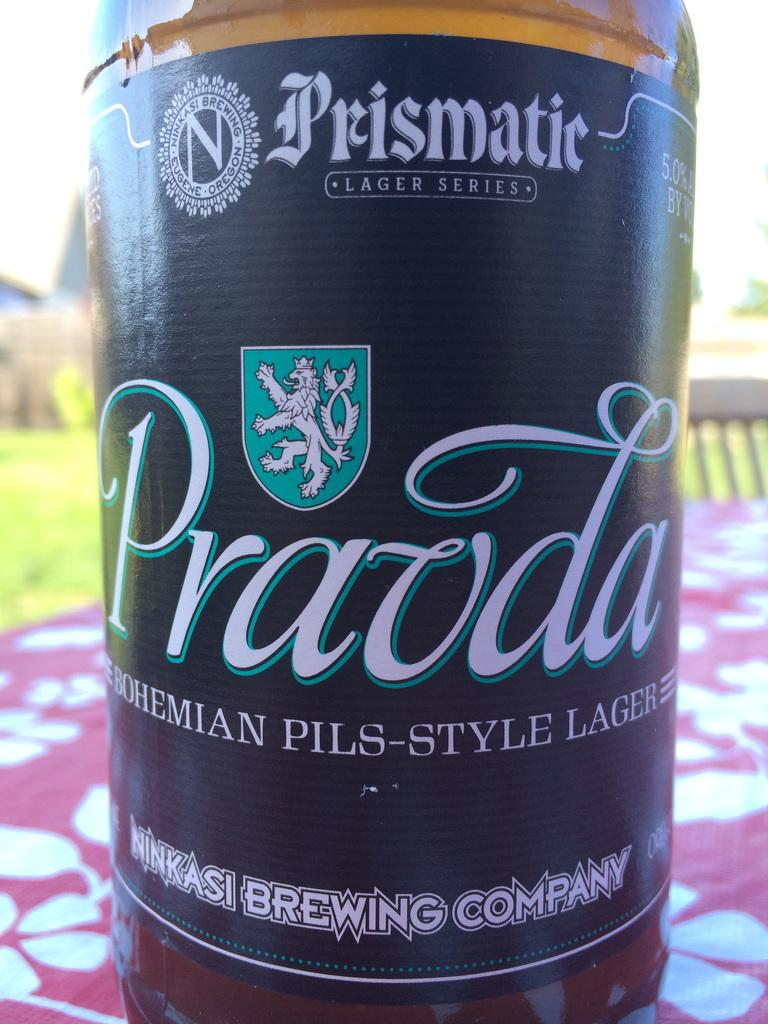Provide a one-sentence caption for the provided image. A beer bottle that says Pravda is on an outdoor picnic table. 